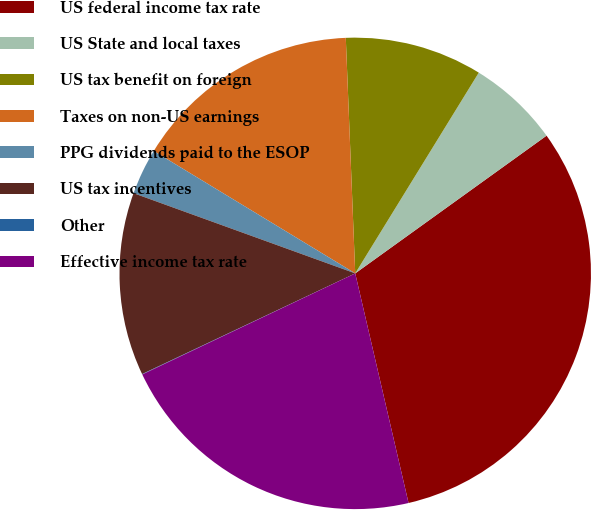<chart> <loc_0><loc_0><loc_500><loc_500><pie_chart><fcel>US federal income tax rate<fcel>US State and local taxes<fcel>US tax benefit on foreign<fcel>Taxes on non-US earnings<fcel>PPG dividends paid to the ESOP<fcel>US tax incentives<fcel>Other<fcel>Effective income tax rate<nl><fcel>31.3%<fcel>6.29%<fcel>9.42%<fcel>15.68%<fcel>3.16%<fcel>12.55%<fcel>0.03%<fcel>21.58%<nl></chart> 